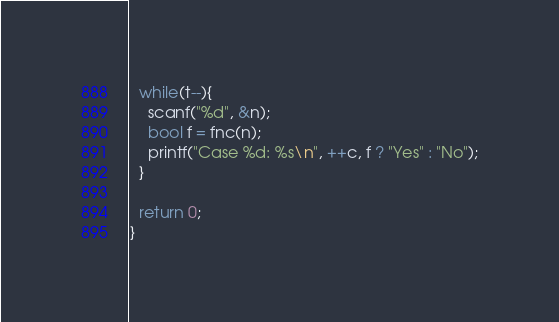<code> <loc_0><loc_0><loc_500><loc_500><_C++_>  while(t--){
    scanf("%d", &n);
    bool f = fnc(n);
    printf("Case %d: %s\n", ++c, f ? "Yes" : "No");
  }
  
  return 0;
}</code> 